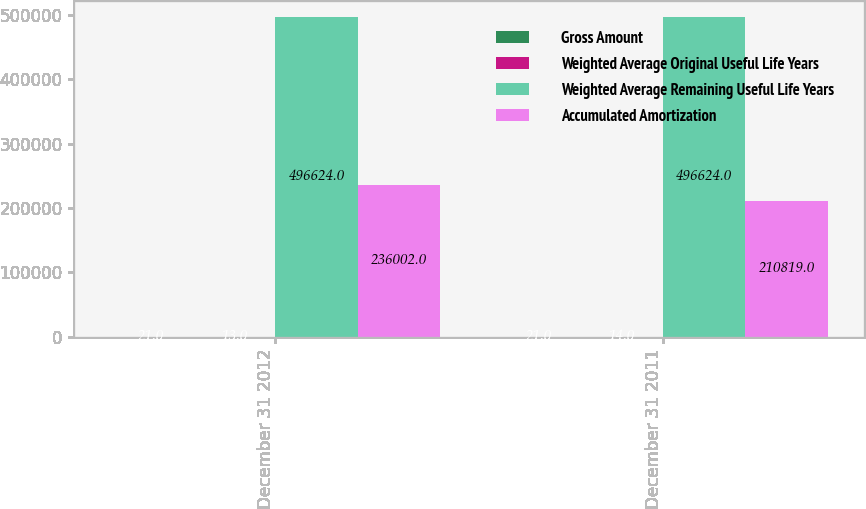<chart> <loc_0><loc_0><loc_500><loc_500><stacked_bar_chart><ecel><fcel>December 31 2012<fcel>December 31 2011<nl><fcel>Gross Amount<fcel>21<fcel>21<nl><fcel>Weighted Average Original Useful Life Years<fcel>13<fcel>14<nl><fcel>Weighted Average Remaining Useful Life Years<fcel>496624<fcel>496624<nl><fcel>Accumulated Amortization<fcel>236002<fcel>210819<nl></chart> 